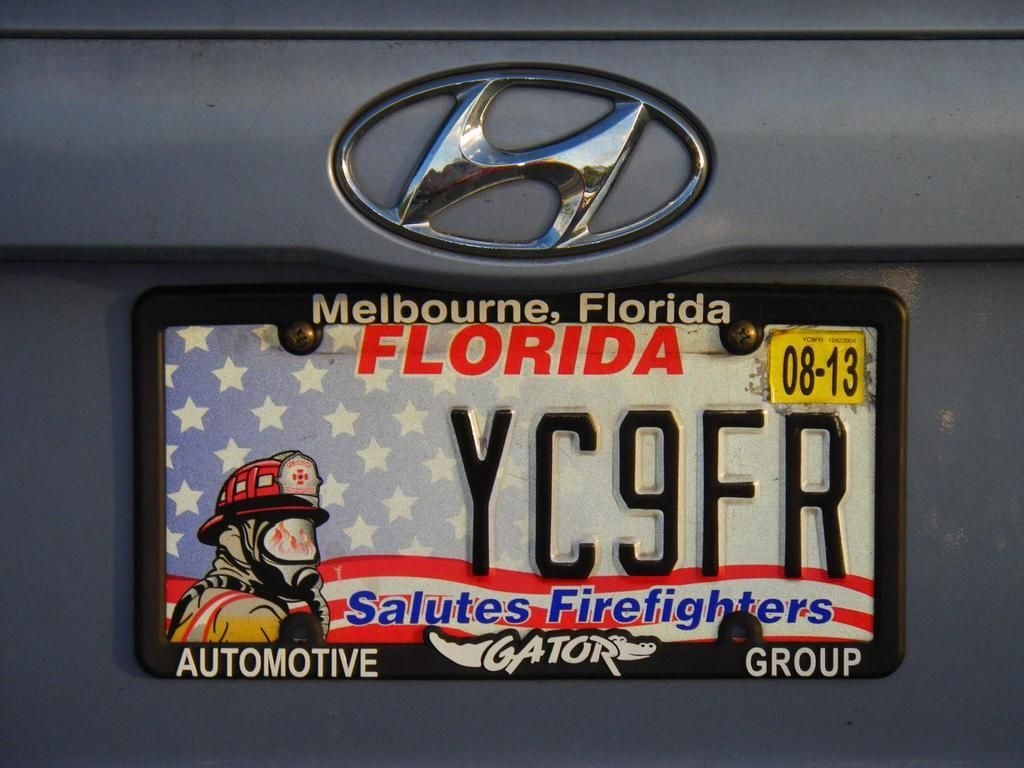Provide a one-sentence caption for the provided image. license plate for Florida that salutes American firefighters. 